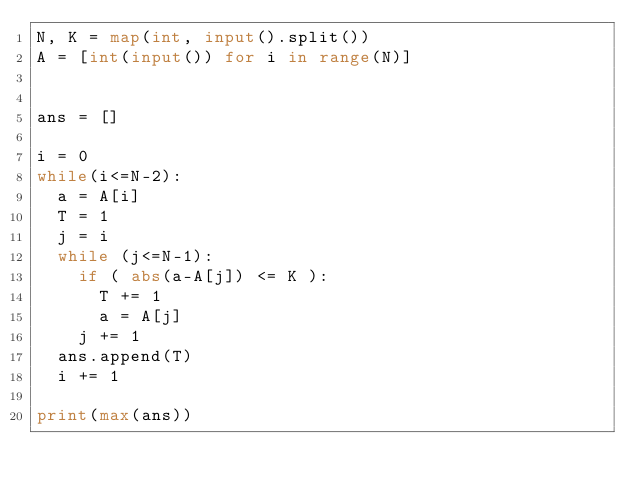<code> <loc_0><loc_0><loc_500><loc_500><_Python_>N, K = map(int, input().split())
A = [int(input()) for i in range(N)]
 
 
ans = []
 
i = 0
while(i<=N-2):
  a = A[i]
  T = 1
  j = i
  while (j<=N-1):
    if ( abs(a-A[j]) <= K ):
      T += 1
      a = A[j]
    j += 1
  ans.append(T)
  i += 1
  
print(max(ans))</code> 